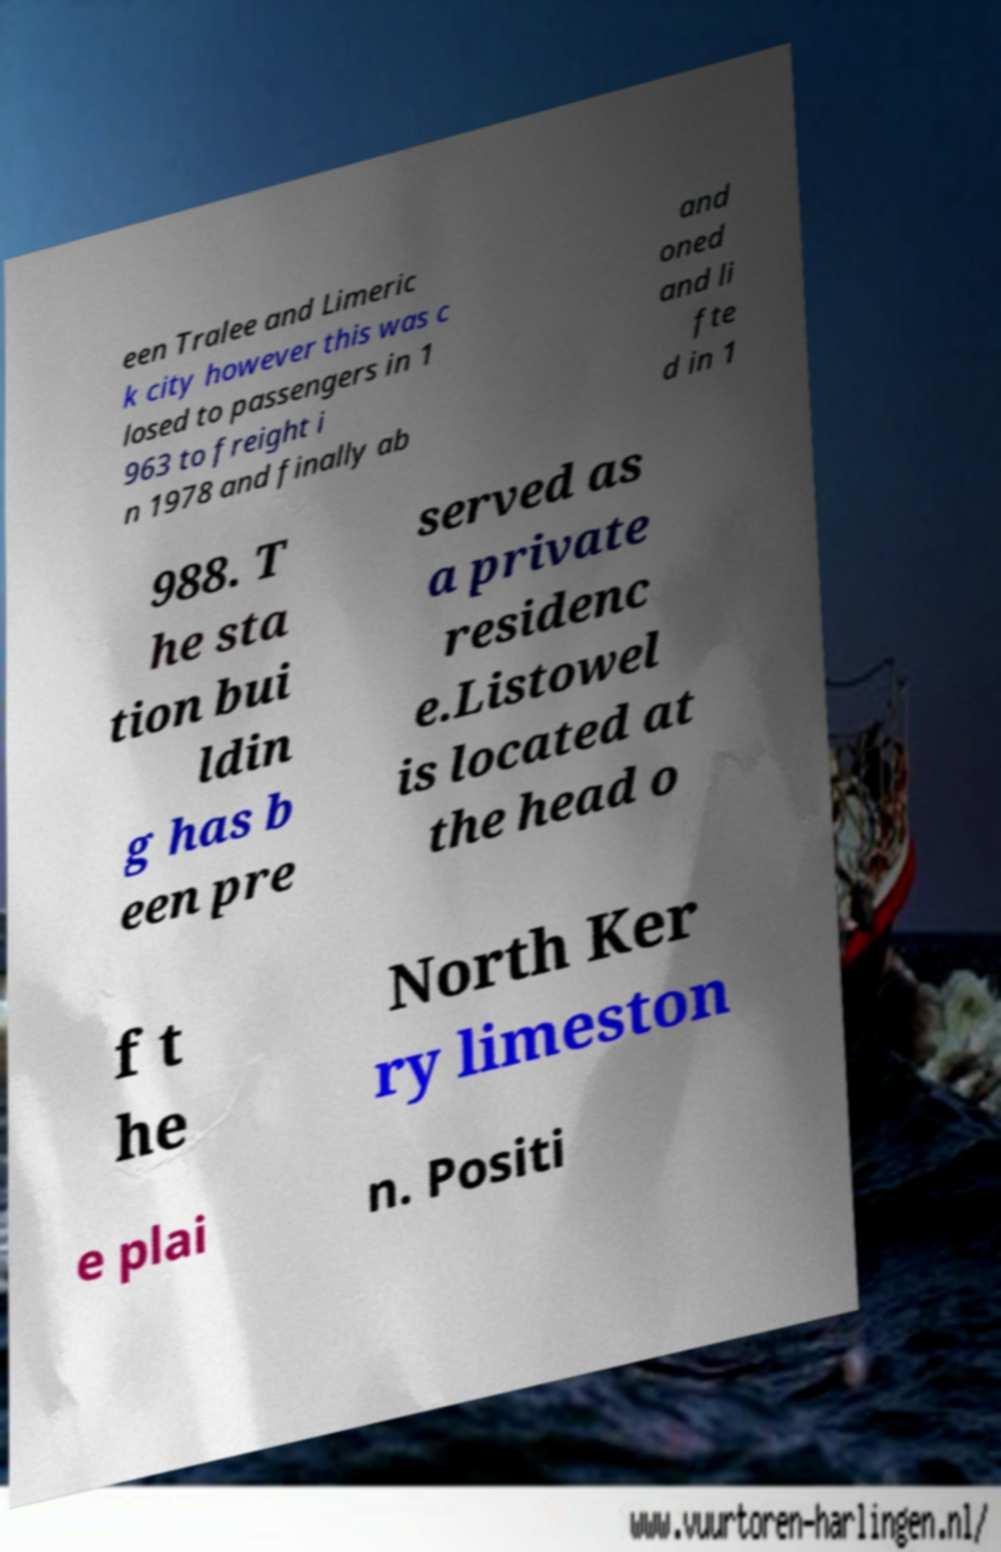Please identify and transcribe the text found in this image. een Tralee and Limeric k city however this was c losed to passengers in 1 963 to freight i n 1978 and finally ab and oned and li fte d in 1 988. T he sta tion bui ldin g has b een pre served as a private residenc e.Listowel is located at the head o f t he North Ker ry limeston e plai n. Positi 